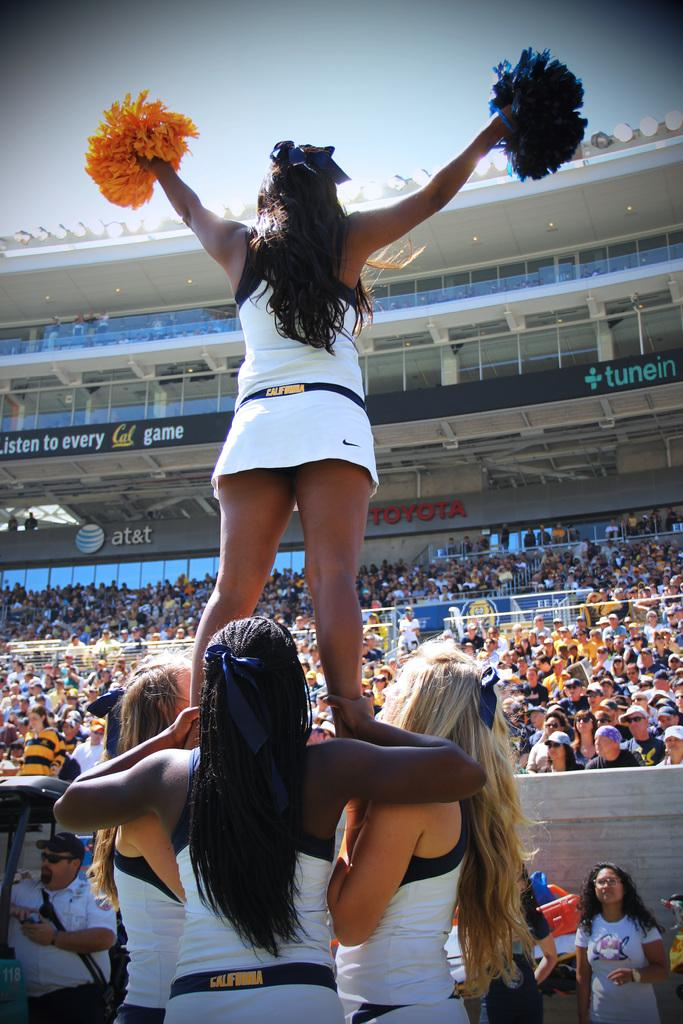<image>
Relay a brief, clear account of the picture shown. Cheerleaders with California on the band of their skirts are making a pyramid. 